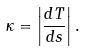<formula> <loc_0><loc_0><loc_500><loc_500>\kappa = \left | \frac { d T } { d s } \right | .</formula> 